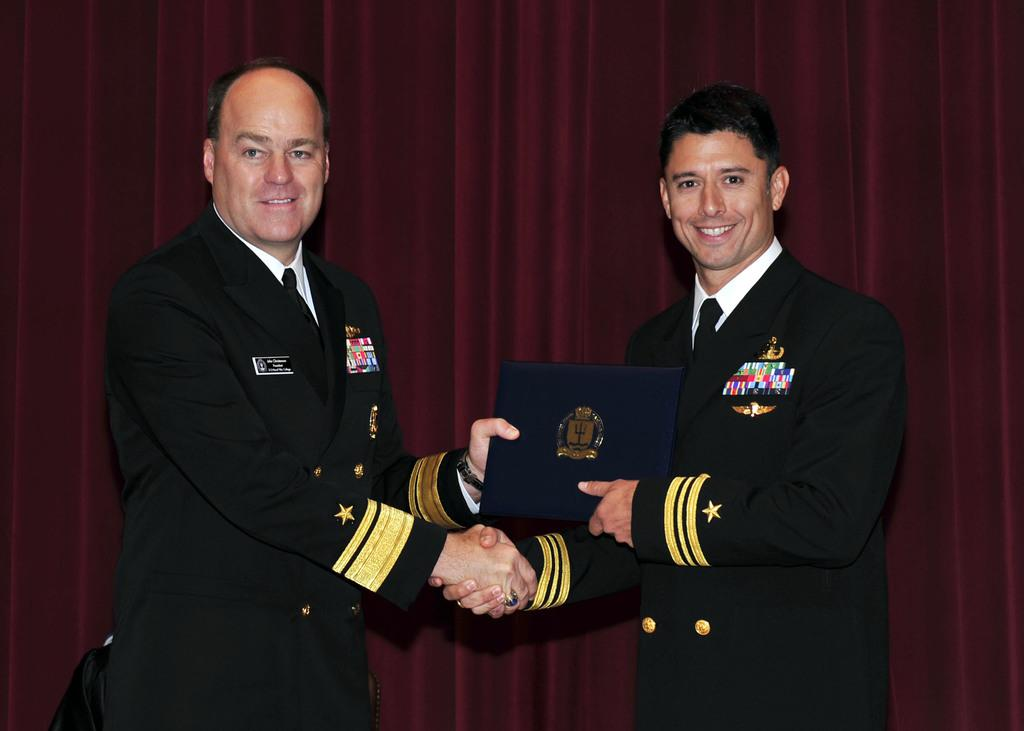How many people are in the image? There are two persons in the image. What are the two persons doing in the image? The two persons are holding an object and shaking their hands. What can be seen in the background of the image? There is cloth visible in the background of the image. What type of yarn is being used by the persons in the image? There is no yarn present in the image; the two persons are shaking their hands while holding an object. Can you see a gate in the image? There is no gate present in the image. 